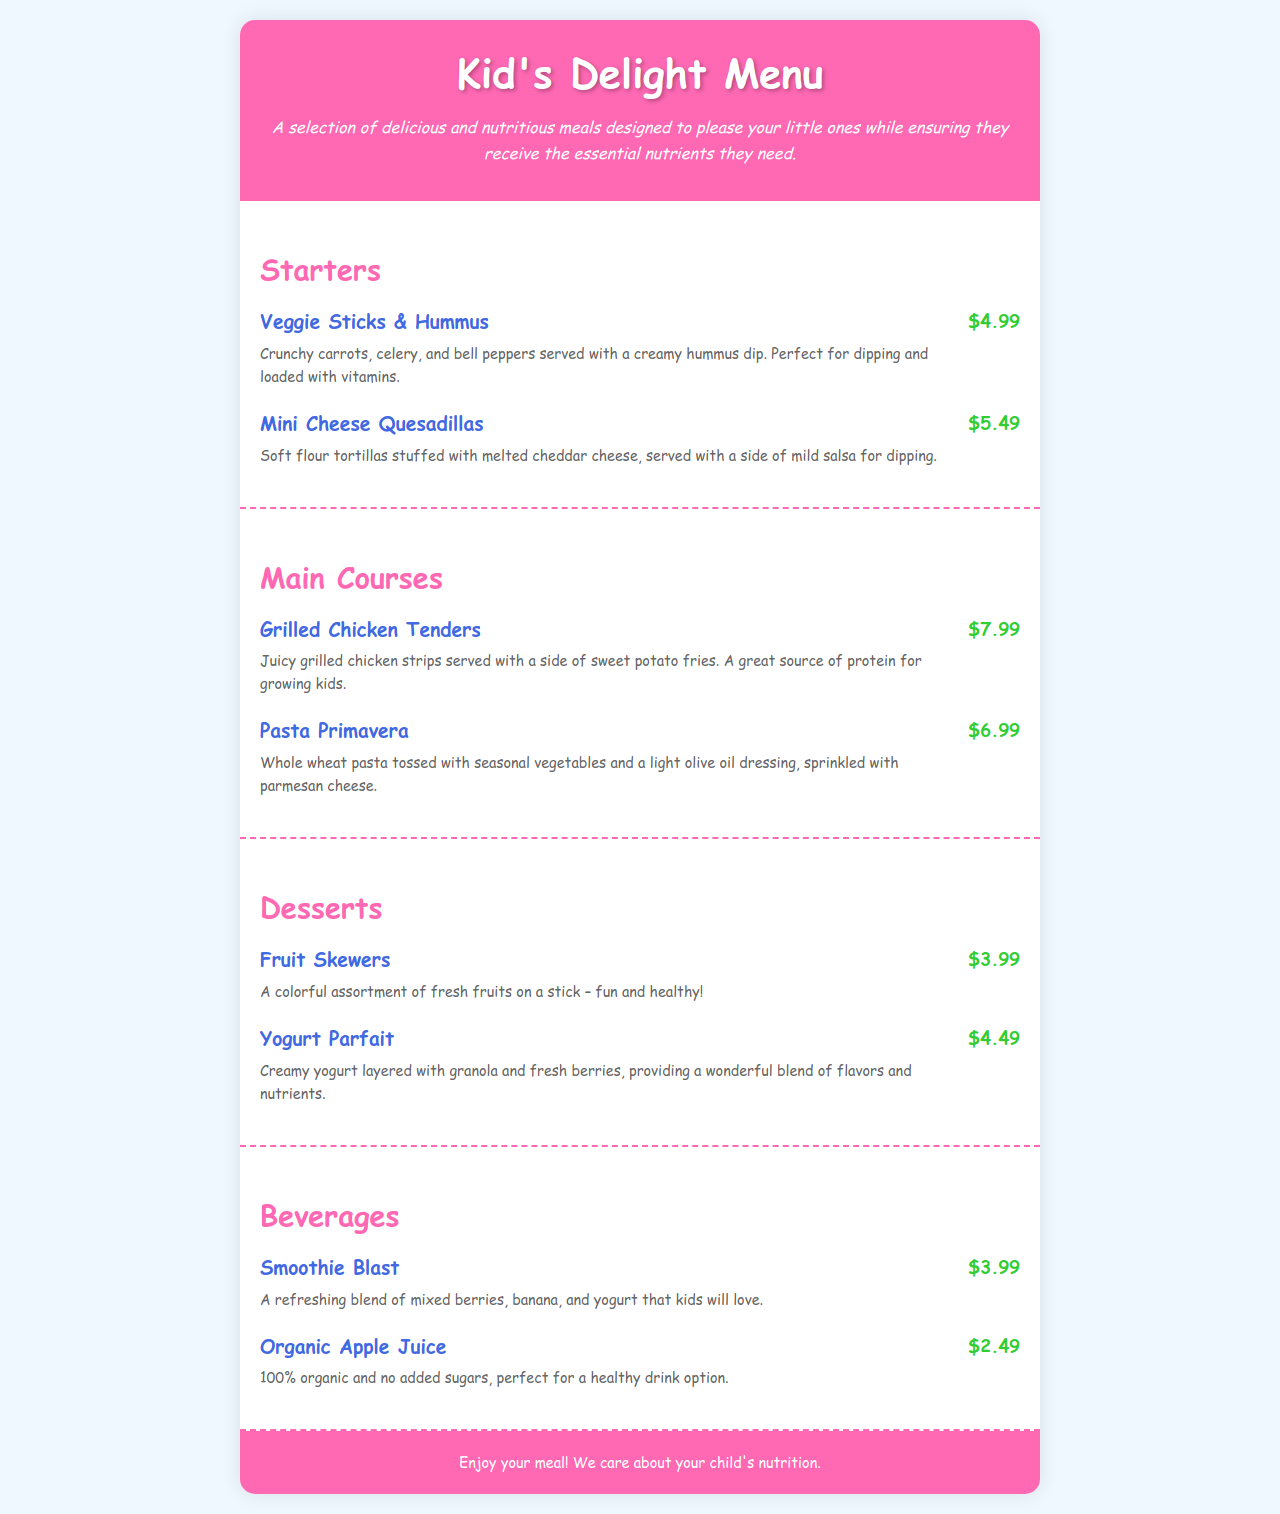What is the name of the first starter? The first starter listed in the menu is "Veggie Sticks & Hummus".
Answer: Veggie Sticks & Hummus How much do Mini Cheese Quesadillas cost? The price for Mini Cheese Quesadillas is mentioned next to the item.
Answer: $5.49 What is the main ingredient in the Grilled Chicken Tenders? The menu states that Grilled Chicken Tenders are made from grilled chicken strips.
Answer: Chicken strips How many desserts are on the menu? The document lists two desserts under the Desserts section.
Answer: 2 What type of beverage is Organic Apple Juice? The document describes Organic Apple Juice as a healthy drink option with no added sugars.
Answer: Healthy Which main course is vegetarian? The Pasta Primavera is described as being made with seasonal vegetables and whole wheat pasta, indicating it is vegetarian.
Answer: Pasta Primavera What is included in the Smoothie Blast? The Smoothie Blast contains mixed berries, banana, and yogurt according to the description.
Answer: Mixed berries, banana, yogurt What is the description of Fruit Skewers? The description of Fruit Skewers mentions a colorful assortment of fresh fruits.
Answer: Colorful assortment of fresh fruits How is the yogurt in the Yogurt Parfait layered? The Yogurt Parfait is layered with granola and fresh berries according to the menu.
Answer: Granola and fresh berries 